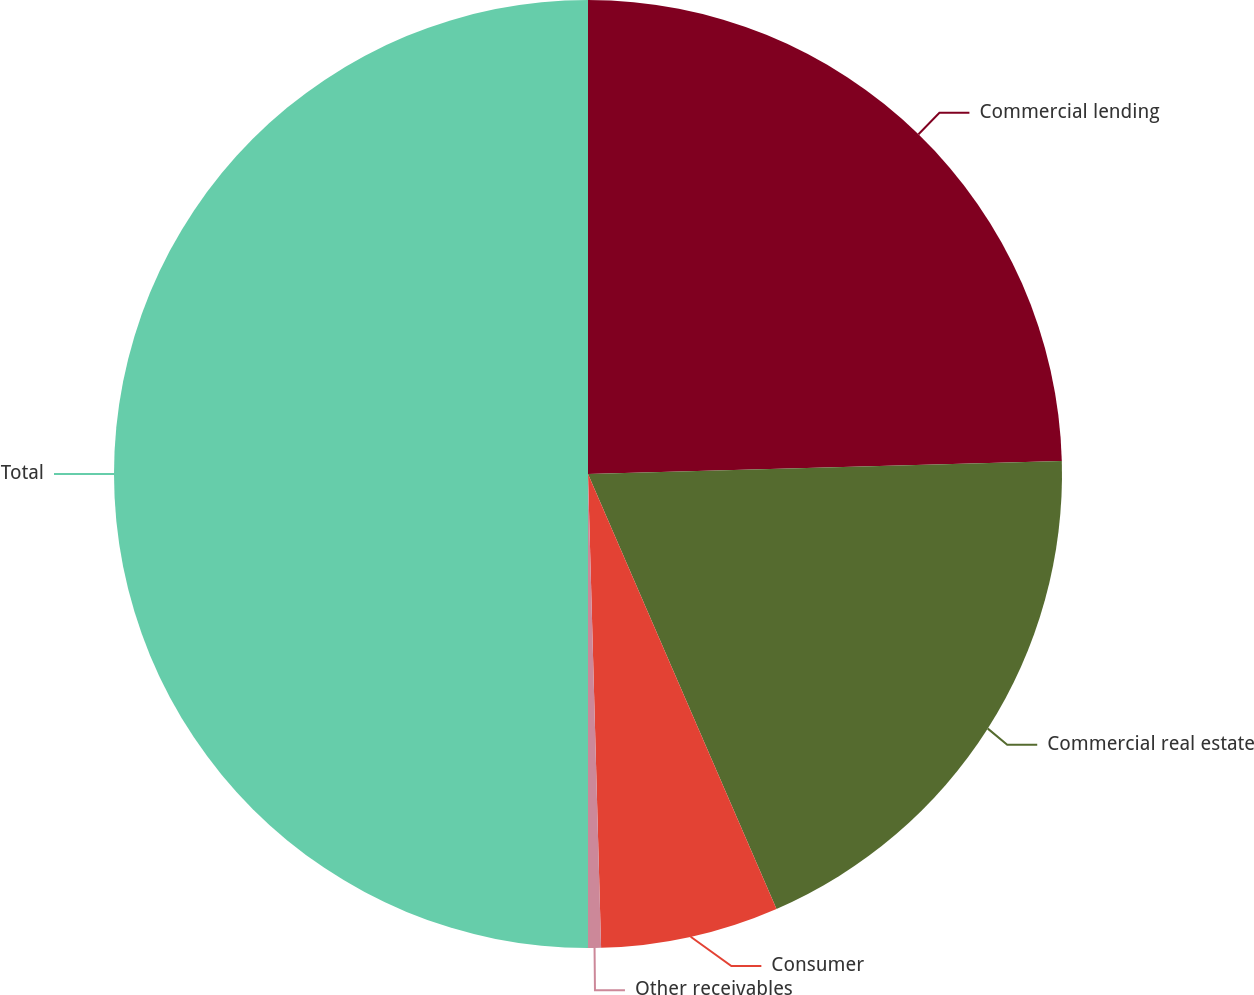<chart> <loc_0><loc_0><loc_500><loc_500><pie_chart><fcel>Commercial lending<fcel>Commercial real estate<fcel>Consumer<fcel>Other receivables<fcel>Total<nl><fcel>24.56%<fcel>18.93%<fcel>6.07%<fcel>0.44%<fcel>50.0%<nl></chart> 